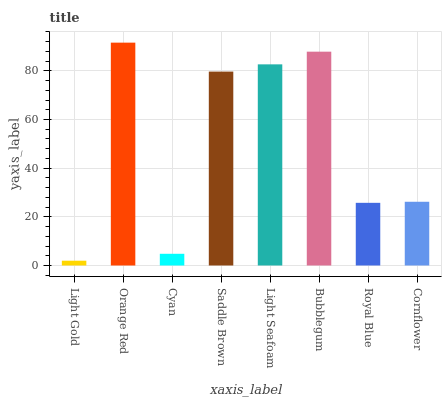Is Light Gold the minimum?
Answer yes or no. Yes. Is Orange Red the maximum?
Answer yes or no. Yes. Is Cyan the minimum?
Answer yes or no. No. Is Cyan the maximum?
Answer yes or no. No. Is Orange Red greater than Cyan?
Answer yes or no. Yes. Is Cyan less than Orange Red?
Answer yes or no. Yes. Is Cyan greater than Orange Red?
Answer yes or no. No. Is Orange Red less than Cyan?
Answer yes or no. No. Is Saddle Brown the high median?
Answer yes or no. Yes. Is Cornflower the low median?
Answer yes or no. Yes. Is Cornflower the high median?
Answer yes or no. No. Is Orange Red the low median?
Answer yes or no. No. 